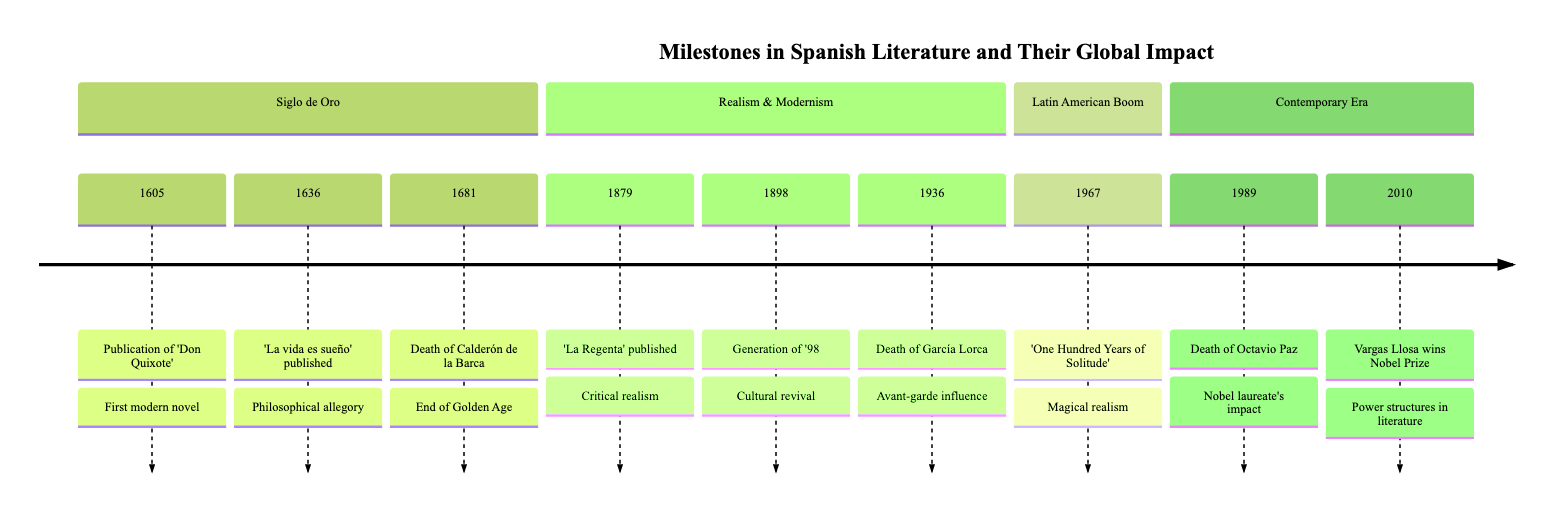What year was 'Don Quixote' published? The timeline indicates the year 1605 next to the event of the publication of 'Don Quixote' by Miguel de Cervantes. Therefore, that is the year it was published.
Answer: 1605 Who authored 'La vida es sueño'? The timeline lists 'La vida es sueño' published in 1636, and it specifies that Pedro Calderón de la Barca is the author of this play.
Answer: Pedro Calderón de la Barca What event marks the end of the Spanish Golden Age? The timeline shows that the death of Pedro Calderón de la Barca in 1681 is indicated as marking the end of the Spanish Golden Age of literature.
Answer: Death of Pedro Calderón de la Barca How many events are in the 'Realism & Modernism' section? By counting the events listed under the 'Realism & Modernism' section, there are three events recorded: 'La Regenta' published, Generation of '98, and the death of García Lorca.
Answer: 3 What literary movement is associated with the year 1967? The timeline shows that in 1967, Gabriel García Márquez's 'One Hundred Years of Solitude' was published, which is specifically associated with the literary movement of magical realism.
Answer: Magical realism Which author won the Nobel Prize in 2010? The timeline indicates that Mario Vargas Llosa won the Nobel Prize in Literature in the year 2010, as noted in the corresponding event.
Answer: Mario Vargas Llosa What is the significance of the Generation of '98? The timeline describes the Generation of '98 as a pivotal group of Spanish writers that instigated a cultural and literary revival, which influences existential and social literatures globally.
Answer: Cultural and literary revival What is the impact of García Lorca's death in 1936? According to the timeline, the death of Federico García Lorca is noted to have significantly influenced modernist and surrealist movements globally, highlighting his avant-garde contributions.
Answer: Influenced modernist and surrealist movements In which section does 'One Hundred Years of Solitude' appear? The timeline categorizes 'One Hundred Years of Solitude' in the 'Latin American Boom' section, indicating its significance in that literary movement.
Answer: Latin American Boom 